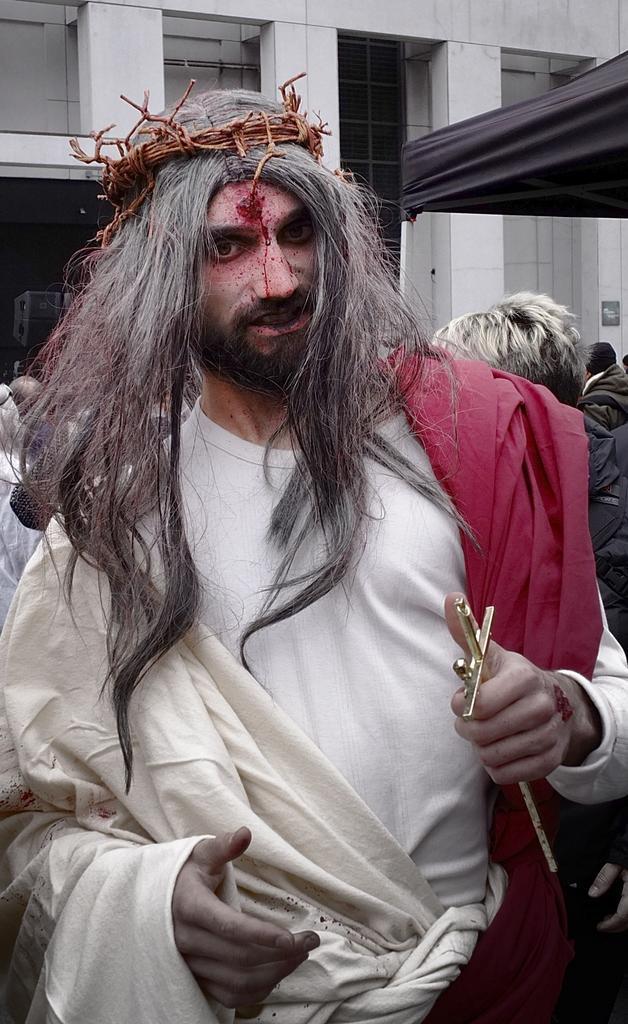Could you give a brief overview of what you see in this image? In the center of the image we can see a man standing. He is wearing a costume and we can see a cross in his hand. In the background there are people and building. 